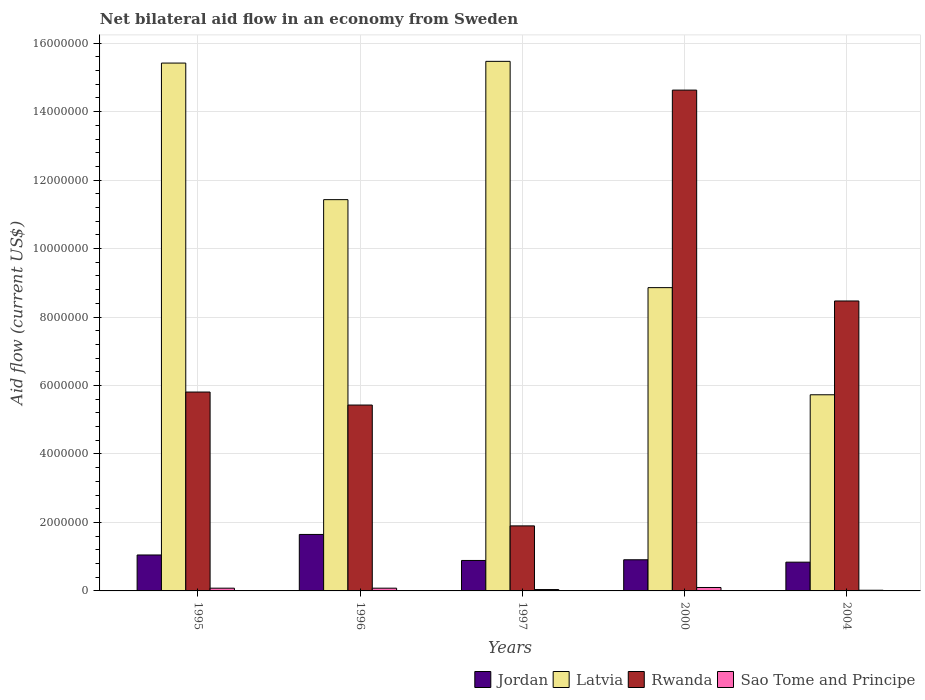How many groups of bars are there?
Ensure brevity in your answer.  5. How many bars are there on the 2nd tick from the left?
Your answer should be very brief. 4. What is the label of the 1st group of bars from the left?
Ensure brevity in your answer.  1995. In how many cases, is the number of bars for a given year not equal to the number of legend labels?
Provide a succinct answer. 0. Across all years, what is the maximum net bilateral aid flow in Latvia?
Your response must be concise. 1.55e+07. Across all years, what is the minimum net bilateral aid flow in Latvia?
Give a very brief answer. 5.73e+06. In which year was the net bilateral aid flow in Sao Tome and Principe maximum?
Keep it short and to the point. 2000. In which year was the net bilateral aid flow in Jordan minimum?
Offer a very short reply. 2004. What is the total net bilateral aid flow in Latvia in the graph?
Ensure brevity in your answer.  5.69e+07. What is the difference between the net bilateral aid flow in Jordan in 1996 and that in 2004?
Provide a succinct answer. 8.10e+05. What is the difference between the net bilateral aid flow in Latvia in 1997 and the net bilateral aid flow in Sao Tome and Principe in 1996?
Offer a terse response. 1.54e+07. What is the average net bilateral aid flow in Sao Tome and Principe per year?
Give a very brief answer. 6.40e+04. In the year 2000, what is the difference between the net bilateral aid flow in Sao Tome and Principe and net bilateral aid flow in Jordan?
Provide a short and direct response. -8.10e+05. In how many years, is the net bilateral aid flow in Jordan greater than 10000000 US$?
Your answer should be compact. 0. What is the difference between the highest and the second highest net bilateral aid flow in Rwanda?
Your answer should be very brief. 6.16e+06. What is the difference between the highest and the lowest net bilateral aid flow in Latvia?
Ensure brevity in your answer.  9.74e+06. Is the sum of the net bilateral aid flow in Rwanda in 1997 and 2000 greater than the maximum net bilateral aid flow in Sao Tome and Principe across all years?
Offer a very short reply. Yes. Is it the case that in every year, the sum of the net bilateral aid flow in Rwanda and net bilateral aid flow in Jordan is greater than the sum of net bilateral aid flow in Sao Tome and Principe and net bilateral aid flow in Latvia?
Give a very brief answer. Yes. What does the 1st bar from the left in 1996 represents?
Keep it short and to the point. Jordan. What does the 1st bar from the right in 2004 represents?
Ensure brevity in your answer.  Sao Tome and Principe. What is the difference between two consecutive major ticks on the Y-axis?
Provide a succinct answer. 2.00e+06. Are the values on the major ticks of Y-axis written in scientific E-notation?
Your response must be concise. No. Does the graph contain grids?
Ensure brevity in your answer.  Yes. Where does the legend appear in the graph?
Ensure brevity in your answer.  Bottom right. What is the title of the graph?
Offer a terse response. Net bilateral aid flow in an economy from Sweden. What is the label or title of the X-axis?
Offer a very short reply. Years. What is the Aid flow (current US$) in Jordan in 1995?
Give a very brief answer. 1.05e+06. What is the Aid flow (current US$) of Latvia in 1995?
Your answer should be compact. 1.54e+07. What is the Aid flow (current US$) of Rwanda in 1995?
Keep it short and to the point. 5.81e+06. What is the Aid flow (current US$) in Sao Tome and Principe in 1995?
Provide a short and direct response. 8.00e+04. What is the Aid flow (current US$) in Jordan in 1996?
Your response must be concise. 1.65e+06. What is the Aid flow (current US$) of Latvia in 1996?
Offer a very short reply. 1.14e+07. What is the Aid flow (current US$) in Rwanda in 1996?
Provide a succinct answer. 5.43e+06. What is the Aid flow (current US$) in Sao Tome and Principe in 1996?
Provide a short and direct response. 8.00e+04. What is the Aid flow (current US$) of Jordan in 1997?
Ensure brevity in your answer.  8.90e+05. What is the Aid flow (current US$) in Latvia in 1997?
Your answer should be very brief. 1.55e+07. What is the Aid flow (current US$) of Rwanda in 1997?
Your answer should be compact. 1.90e+06. What is the Aid flow (current US$) in Jordan in 2000?
Offer a terse response. 9.10e+05. What is the Aid flow (current US$) of Latvia in 2000?
Offer a very short reply. 8.86e+06. What is the Aid flow (current US$) of Rwanda in 2000?
Give a very brief answer. 1.46e+07. What is the Aid flow (current US$) of Sao Tome and Principe in 2000?
Your answer should be compact. 1.00e+05. What is the Aid flow (current US$) of Jordan in 2004?
Your answer should be compact. 8.40e+05. What is the Aid flow (current US$) of Latvia in 2004?
Ensure brevity in your answer.  5.73e+06. What is the Aid flow (current US$) in Rwanda in 2004?
Your answer should be compact. 8.47e+06. What is the Aid flow (current US$) in Sao Tome and Principe in 2004?
Offer a terse response. 2.00e+04. Across all years, what is the maximum Aid flow (current US$) of Jordan?
Keep it short and to the point. 1.65e+06. Across all years, what is the maximum Aid flow (current US$) of Latvia?
Ensure brevity in your answer.  1.55e+07. Across all years, what is the maximum Aid flow (current US$) in Rwanda?
Keep it short and to the point. 1.46e+07. Across all years, what is the maximum Aid flow (current US$) in Sao Tome and Principe?
Your response must be concise. 1.00e+05. Across all years, what is the minimum Aid flow (current US$) of Jordan?
Provide a short and direct response. 8.40e+05. Across all years, what is the minimum Aid flow (current US$) of Latvia?
Provide a short and direct response. 5.73e+06. Across all years, what is the minimum Aid flow (current US$) of Rwanda?
Provide a short and direct response. 1.90e+06. Across all years, what is the minimum Aid flow (current US$) of Sao Tome and Principe?
Provide a succinct answer. 2.00e+04. What is the total Aid flow (current US$) in Jordan in the graph?
Provide a short and direct response. 5.34e+06. What is the total Aid flow (current US$) in Latvia in the graph?
Offer a terse response. 5.69e+07. What is the total Aid flow (current US$) of Rwanda in the graph?
Make the answer very short. 3.62e+07. What is the difference between the Aid flow (current US$) of Jordan in 1995 and that in 1996?
Provide a short and direct response. -6.00e+05. What is the difference between the Aid flow (current US$) in Latvia in 1995 and that in 1996?
Keep it short and to the point. 3.99e+06. What is the difference between the Aid flow (current US$) in Rwanda in 1995 and that in 1996?
Your answer should be very brief. 3.80e+05. What is the difference between the Aid flow (current US$) of Sao Tome and Principe in 1995 and that in 1996?
Keep it short and to the point. 0. What is the difference between the Aid flow (current US$) in Jordan in 1995 and that in 1997?
Keep it short and to the point. 1.60e+05. What is the difference between the Aid flow (current US$) of Rwanda in 1995 and that in 1997?
Provide a short and direct response. 3.91e+06. What is the difference between the Aid flow (current US$) of Latvia in 1995 and that in 2000?
Make the answer very short. 6.56e+06. What is the difference between the Aid flow (current US$) of Rwanda in 1995 and that in 2000?
Provide a short and direct response. -8.82e+06. What is the difference between the Aid flow (current US$) in Sao Tome and Principe in 1995 and that in 2000?
Your answer should be compact. -2.00e+04. What is the difference between the Aid flow (current US$) of Latvia in 1995 and that in 2004?
Provide a short and direct response. 9.69e+06. What is the difference between the Aid flow (current US$) of Rwanda in 1995 and that in 2004?
Your answer should be very brief. -2.66e+06. What is the difference between the Aid flow (current US$) in Sao Tome and Principe in 1995 and that in 2004?
Your response must be concise. 6.00e+04. What is the difference between the Aid flow (current US$) of Jordan in 1996 and that in 1997?
Make the answer very short. 7.60e+05. What is the difference between the Aid flow (current US$) in Latvia in 1996 and that in 1997?
Offer a very short reply. -4.04e+06. What is the difference between the Aid flow (current US$) of Rwanda in 1996 and that in 1997?
Your answer should be compact. 3.53e+06. What is the difference between the Aid flow (current US$) of Jordan in 1996 and that in 2000?
Offer a very short reply. 7.40e+05. What is the difference between the Aid flow (current US$) of Latvia in 1996 and that in 2000?
Your answer should be very brief. 2.57e+06. What is the difference between the Aid flow (current US$) in Rwanda in 1996 and that in 2000?
Your answer should be very brief. -9.20e+06. What is the difference between the Aid flow (current US$) in Sao Tome and Principe in 1996 and that in 2000?
Your answer should be compact. -2.00e+04. What is the difference between the Aid flow (current US$) in Jordan in 1996 and that in 2004?
Your response must be concise. 8.10e+05. What is the difference between the Aid flow (current US$) of Latvia in 1996 and that in 2004?
Provide a short and direct response. 5.70e+06. What is the difference between the Aid flow (current US$) of Rwanda in 1996 and that in 2004?
Offer a very short reply. -3.04e+06. What is the difference between the Aid flow (current US$) in Sao Tome and Principe in 1996 and that in 2004?
Ensure brevity in your answer.  6.00e+04. What is the difference between the Aid flow (current US$) of Jordan in 1997 and that in 2000?
Your answer should be compact. -2.00e+04. What is the difference between the Aid flow (current US$) of Latvia in 1997 and that in 2000?
Give a very brief answer. 6.61e+06. What is the difference between the Aid flow (current US$) of Rwanda in 1997 and that in 2000?
Ensure brevity in your answer.  -1.27e+07. What is the difference between the Aid flow (current US$) of Sao Tome and Principe in 1997 and that in 2000?
Offer a very short reply. -6.00e+04. What is the difference between the Aid flow (current US$) in Jordan in 1997 and that in 2004?
Your answer should be compact. 5.00e+04. What is the difference between the Aid flow (current US$) in Latvia in 1997 and that in 2004?
Provide a succinct answer. 9.74e+06. What is the difference between the Aid flow (current US$) in Rwanda in 1997 and that in 2004?
Your response must be concise. -6.57e+06. What is the difference between the Aid flow (current US$) of Sao Tome and Principe in 1997 and that in 2004?
Offer a terse response. 2.00e+04. What is the difference between the Aid flow (current US$) of Jordan in 2000 and that in 2004?
Your response must be concise. 7.00e+04. What is the difference between the Aid flow (current US$) of Latvia in 2000 and that in 2004?
Your answer should be very brief. 3.13e+06. What is the difference between the Aid flow (current US$) of Rwanda in 2000 and that in 2004?
Your answer should be compact. 6.16e+06. What is the difference between the Aid flow (current US$) in Sao Tome and Principe in 2000 and that in 2004?
Keep it short and to the point. 8.00e+04. What is the difference between the Aid flow (current US$) in Jordan in 1995 and the Aid flow (current US$) in Latvia in 1996?
Your answer should be compact. -1.04e+07. What is the difference between the Aid flow (current US$) in Jordan in 1995 and the Aid flow (current US$) in Rwanda in 1996?
Offer a terse response. -4.38e+06. What is the difference between the Aid flow (current US$) of Jordan in 1995 and the Aid flow (current US$) of Sao Tome and Principe in 1996?
Offer a terse response. 9.70e+05. What is the difference between the Aid flow (current US$) of Latvia in 1995 and the Aid flow (current US$) of Rwanda in 1996?
Your response must be concise. 9.99e+06. What is the difference between the Aid flow (current US$) of Latvia in 1995 and the Aid flow (current US$) of Sao Tome and Principe in 1996?
Give a very brief answer. 1.53e+07. What is the difference between the Aid flow (current US$) in Rwanda in 1995 and the Aid flow (current US$) in Sao Tome and Principe in 1996?
Your response must be concise. 5.73e+06. What is the difference between the Aid flow (current US$) of Jordan in 1995 and the Aid flow (current US$) of Latvia in 1997?
Your answer should be very brief. -1.44e+07. What is the difference between the Aid flow (current US$) of Jordan in 1995 and the Aid flow (current US$) of Rwanda in 1997?
Offer a very short reply. -8.50e+05. What is the difference between the Aid flow (current US$) in Jordan in 1995 and the Aid flow (current US$) in Sao Tome and Principe in 1997?
Keep it short and to the point. 1.01e+06. What is the difference between the Aid flow (current US$) of Latvia in 1995 and the Aid flow (current US$) of Rwanda in 1997?
Your answer should be compact. 1.35e+07. What is the difference between the Aid flow (current US$) in Latvia in 1995 and the Aid flow (current US$) in Sao Tome and Principe in 1997?
Make the answer very short. 1.54e+07. What is the difference between the Aid flow (current US$) of Rwanda in 1995 and the Aid flow (current US$) of Sao Tome and Principe in 1997?
Your response must be concise. 5.77e+06. What is the difference between the Aid flow (current US$) of Jordan in 1995 and the Aid flow (current US$) of Latvia in 2000?
Your answer should be very brief. -7.81e+06. What is the difference between the Aid flow (current US$) of Jordan in 1995 and the Aid flow (current US$) of Rwanda in 2000?
Ensure brevity in your answer.  -1.36e+07. What is the difference between the Aid flow (current US$) in Jordan in 1995 and the Aid flow (current US$) in Sao Tome and Principe in 2000?
Provide a succinct answer. 9.50e+05. What is the difference between the Aid flow (current US$) in Latvia in 1995 and the Aid flow (current US$) in Rwanda in 2000?
Give a very brief answer. 7.90e+05. What is the difference between the Aid flow (current US$) in Latvia in 1995 and the Aid flow (current US$) in Sao Tome and Principe in 2000?
Offer a very short reply. 1.53e+07. What is the difference between the Aid flow (current US$) of Rwanda in 1995 and the Aid flow (current US$) of Sao Tome and Principe in 2000?
Give a very brief answer. 5.71e+06. What is the difference between the Aid flow (current US$) of Jordan in 1995 and the Aid flow (current US$) of Latvia in 2004?
Offer a terse response. -4.68e+06. What is the difference between the Aid flow (current US$) in Jordan in 1995 and the Aid flow (current US$) in Rwanda in 2004?
Provide a succinct answer. -7.42e+06. What is the difference between the Aid flow (current US$) in Jordan in 1995 and the Aid flow (current US$) in Sao Tome and Principe in 2004?
Your response must be concise. 1.03e+06. What is the difference between the Aid flow (current US$) of Latvia in 1995 and the Aid flow (current US$) of Rwanda in 2004?
Offer a very short reply. 6.95e+06. What is the difference between the Aid flow (current US$) of Latvia in 1995 and the Aid flow (current US$) of Sao Tome and Principe in 2004?
Give a very brief answer. 1.54e+07. What is the difference between the Aid flow (current US$) in Rwanda in 1995 and the Aid flow (current US$) in Sao Tome and Principe in 2004?
Provide a succinct answer. 5.79e+06. What is the difference between the Aid flow (current US$) of Jordan in 1996 and the Aid flow (current US$) of Latvia in 1997?
Offer a very short reply. -1.38e+07. What is the difference between the Aid flow (current US$) of Jordan in 1996 and the Aid flow (current US$) of Sao Tome and Principe in 1997?
Ensure brevity in your answer.  1.61e+06. What is the difference between the Aid flow (current US$) of Latvia in 1996 and the Aid flow (current US$) of Rwanda in 1997?
Provide a short and direct response. 9.53e+06. What is the difference between the Aid flow (current US$) in Latvia in 1996 and the Aid flow (current US$) in Sao Tome and Principe in 1997?
Your answer should be compact. 1.14e+07. What is the difference between the Aid flow (current US$) in Rwanda in 1996 and the Aid flow (current US$) in Sao Tome and Principe in 1997?
Provide a short and direct response. 5.39e+06. What is the difference between the Aid flow (current US$) of Jordan in 1996 and the Aid flow (current US$) of Latvia in 2000?
Give a very brief answer. -7.21e+06. What is the difference between the Aid flow (current US$) in Jordan in 1996 and the Aid flow (current US$) in Rwanda in 2000?
Offer a very short reply. -1.30e+07. What is the difference between the Aid flow (current US$) of Jordan in 1996 and the Aid flow (current US$) of Sao Tome and Principe in 2000?
Provide a short and direct response. 1.55e+06. What is the difference between the Aid flow (current US$) in Latvia in 1996 and the Aid flow (current US$) in Rwanda in 2000?
Provide a succinct answer. -3.20e+06. What is the difference between the Aid flow (current US$) in Latvia in 1996 and the Aid flow (current US$) in Sao Tome and Principe in 2000?
Your answer should be very brief. 1.13e+07. What is the difference between the Aid flow (current US$) in Rwanda in 1996 and the Aid flow (current US$) in Sao Tome and Principe in 2000?
Make the answer very short. 5.33e+06. What is the difference between the Aid flow (current US$) of Jordan in 1996 and the Aid flow (current US$) of Latvia in 2004?
Ensure brevity in your answer.  -4.08e+06. What is the difference between the Aid flow (current US$) of Jordan in 1996 and the Aid flow (current US$) of Rwanda in 2004?
Your response must be concise. -6.82e+06. What is the difference between the Aid flow (current US$) of Jordan in 1996 and the Aid flow (current US$) of Sao Tome and Principe in 2004?
Your answer should be very brief. 1.63e+06. What is the difference between the Aid flow (current US$) in Latvia in 1996 and the Aid flow (current US$) in Rwanda in 2004?
Make the answer very short. 2.96e+06. What is the difference between the Aid flow (current US$) of Latvia in 1996 and the Aid flow (current US$) of Sao Tome and Principe in 2004?
Your response must be concise. 1.14e+07. What is the difference between the Aid flow (current US$) of Rwanda in 1996 and the Aid flow (current US$) of Sao Tome and Principe in 2004?
Your answer should be compact. 5.41e+06. What is the difference between the Aid flow (current US$) of Jordan in 1997 and the Aid flow (current US$) of Latvia in 2000?
Your answer should be compact. -7.97e+06. What is the difference between the Aid flow (current US$) of Jordan in 1997 and the Aid flow (current US$) of Rwanda in 2000?
Offer a terse response. -1.37e+07. What is the difference between the Aid flow (current US$) of Jordan in 1997 and the Aid flow (current US$) of Sao Tome and Principe in 2000?
Provide a succinct answer. 7.90e+05. What is the difference between the Aid flow (current US$) in Latvia in 1997 and the Aid flow (current US$) in Rwanda in 2000?
Offer a terse response. 8.40e+05. What is the difference between the Aid flow (current US$) in Latvia in 1997 and the Aid flow (current US$) in Sao Tome and Principe in 2000?
Provide a short and direct response. 1.54e+07. What is the difference between the Aid flow (current US$) in Rwanda in 1997 and the Aid flow (current US$) in Sao Tome and Principe in 2000?
Give a very brief answer. 1.80e+06. What is the difference between the Aid flow (current US$) in Jordan in 1997 and the Aid flow (current US$) in Latvia in 2004?
Make the answer very short. -4.84e+06. What is the difference between the Aid flow (current US$) of Jordan in 1997 and the Aid flow (current US$) of Rwanda in 2004?
Offer a terse response. -7.58e+06. What is the difference between the Aid flow (current US$) of Jordan in 1997 and the Aid flow (current US$) of Sao Tome and Principe in 2004?
Your answer should be compact. 8.70e+05. What is the difference between the Aid flow (current US$) in Latvia in 1997 and the Aid flow (current US$) in Sao Tome and Principe in 2004?
Offer a very short reply. 1.54e+07. What is the difference between the Aid flow (current US$) of Rwanda in 1997 and the Aid flow (current US$) of Sao Tome and Principe in 2004?
Provide a succinct answer. 1.88e+06. What is the difference between the Aid flow (current US$) in Jordan in 2000 and the Aid flow (current US$) in Latvia in 2004?
Ensure brevity in your answer.  -4.82e+06. What is the difference between the Aid flow (current US$) in Jordan in 2000 and the Aid flow (current US$) in Rwanda in 2004?
Offer a very short reply. -7.56e+06. What is the difference between the Aid flow (current US$) in Jordan in 2000 and the Aid flow (current US$) in Sao Tome and Principe in 2004?
Offer a terse response. 8.90e+05. What is the difference between the Aid flow (current US$) of Latvia in 2000 and the Aid flow (current US$) of Sao Tome and Principe in 2004?
Make the answer very short. 8.84e+06. What is the difference between the Aid flow (current US$) of Rwanda in 2000 and the Aid flow (current US$) of Sao Tome and Principe in 2004?
Keep it short and to the point. 1.46e+07. What is the average Aid flow (current US$) in Jordan per year?
Give a very brief answer. 1.07e+06. What is the average Aid flow (current US$) of Latvia per year?
Offer a very short reply. 1.14e+07. What is the average Aid flow (current US$) of Rwanda per year?
Keep it short and to the point. 7.25e+06. What is the average Aid flow (current US$) of Sao Tome and Principe per year?
Offer a terse response. 6.40e+04. In the year 1995, what is the difference between the Aid flow (current US$) in Jordan and Aid flow (current US$) in Latvia?
Provide a short and direct response. -1.44e+07. In the year 1995, what is the difference between the Aid flow (current US$) in Jordan and Aid flow (current US$) in Rwanda?
Your answer should be very brief. -4.76e+06. In the year 1995, what is the difference between the Aid flow (current US$) of Jordan and Aid flow (current US$) of Sao Tome and Principe?
Give a very brief answer. 9.70e+05. In the year 1995, what is the difference between the Aid flow (current US$) of Latvia and Aid flow (current US$) of Rwanda?
Your response must be concise. 9.61e+06. In the year 1995, what is the difference between the Aid flow (current US$) of Latvia and Aid flow (current US$) of Sao Tome and Principe?
Keep it short and to the point. 1.53e+07. In the year 1995, what is the difference between the Aid flow (current US$) of Rwanda and Aid flow (current US$) of Sao Tome and Principe?
Keep it short and to the point. 5.73e+06. In the year 1996, what is the difference between the Aid flow (current US$) in Jordan and Aid flow (current US$) in Latvia?
Ensure brevity in your answer.  -9.78e+06. In the year 1996, what is the difference between the Aid flow (current US$) of Jordan and Aid flow (current US$) of Rwanda?
Keep it short and to the point. -3.78e+06. In the year 1996, what is the difference between the Aid flow (current US$) in Jordan and Aid flow (current US$) in Sao Tome and Principe?
Your answer should be very brief. 1.57e+06. In the year 1996, what is the difference between the Aid flow (current US$) of Latvia and Aid flow (current US$) of Sao Tome and Principe?
Your answer should be very brief. 1.14e+07. In the year 1996, what is the difference between the Aid flow (current US$) in Rwanda and Aid flow (current US$) in Sao Tome and Principe?
Keep it short and to the point. 5.35e+06. In the year 1997, what is the difference between the Aid flow (current US$) of Jordan and Aid flow (current US$) of Latvia?
Provide a succinct answer. -1.46e+07. In the year 1997, what is the difference between the Aid flow (current US$) of Jordan and Aid flow (current US$) of Rwanda?
Make the answer very short. -1.01e+06. In the year 1997, what is the difference between the Aid flow (current US$) in Jordan and Aid flow (current US$) in Sao Tome and Principe?
Your response must be concise. 8.50e+05. In the year 1997, what is the difference between the Aid flow (current US$) of Latvia and Aid flow (current US$) of Rwanda?
Offer a very short reply. 1.36e+07. In the year 1997, what is the difference between the Aid flow (current US$) in Latvia and Aid flow (current US$) in Sao Tome and Principe?
Give a very brief answer. 1.54e+07. In the year 1997, what is the difference between the Aid flow (current US$) of Rwanda and Aid flow (current US$) of Sao Tome and Principe?
Make the answer very short. 1.86e+06. In the year 2000, what is the difference between the Aid flow (current US$) of Jordan and Aid flow (current US$) of Latvia?
Provide a short and direct response. -7.95e+06. In the year 2000, what is the difference between the Aid flow (current US$) of Jordan and Aid flow (current US$) of Rwanda?
Provide a short and direct response. -1.37e+07. In the year 2000, what is the difference between the Aid flow (current US$) of Jordan and Aid flow (current US$) of Sao Tome and Principe?
Give a very brief answer. 8.10e+05. In the year 2000, what is the difference between the Aid flow (current US$) of Latvia and Aid flow (current US$) of Rwanda?
Provide a short and direct response. -5.77e+06. In the year 2000, what is the difference between the Aid flow (current US$) of Latvia and Aid flow (current US$) of Sao Tome and Principe?
Keep it short and to the point. 8.76e+06. In the year 2000, what is the difference between the Aid flow (current US$) of Rwanda and Aid flow (current US$) of Sao Tome and Principe?
Your answer should be very brief. 1.45e+07. In the year 2004, what is the difference between the Aid flow (current US$) in Jordan and Aid flow (current US$) in Latvia?
Offer a terse response. -4.89e+06. In the year 2004, what is the difference between the Aid flow (current US$) of Jordan and Aid flow (current US$) of Rwanda?
Give a very brief answer. -7.63e+06. In the year 2004, what is the difference between the Aid flow (current US$) in Jordan and Aid flow (current US$) in Sao Tome and Principe?
Give a very brief answer. 8.20e+05. In the year 2004, what is the difference between the Aid flow (current US$) in Latvia and Aid flow (current US$) in Rwanda?
Your answer should be very brief. -2.74e+06. In the year 2004, what is the difference between the Aid flow (current US$) in Latvia and Aid flow (current US$) in Sao Tome and Principe?
Offer a very short reply. 5.71e+06. In the year 2004, what is the difference between the Aid flow (current US$) in Rwanda and Aid flow (current US$) in Sao Tome and Principe?
Offer a terse response. 8.45e+06. What is the ratio of the Aid flow (current US$) of Jordan in 1995 to that in 1996?
Offer a very short reply. 0.64. What is the ratio of the Aid flow (current US$) in Latvia in 1995 to that in 1996?
Provide a short and direct response. 1.35. What is the ratio of the Aid flow (current US$) of Rwanda in 1995 to that in 1996?
Your answer should be very brief. 1.07. What is the ratio of the Aid flow (current US$) of Jordan in 1995 to that in 1997?
Make the answer very short. 1.18. What is the ratio of the Aid flow (current US$) in Rwanda in 1995 to that in 1997?
Provide a short and direct response. 3.06. What is the ratio of the Aid flow (current US$) in Jordan in 1995 to that in 2000?
Keep it short and to the point. 1.15. What is the ratio of the Aid flow (current US$) of Latvia in 1995 to that in 2000?
Make the answer very short. 1.74. What is the ratio of the Aid flow (current US$) of Rwanda in 1995 to that in 2000?
Offer a very short reply. 0.4. What is the ratio of the Aid flow (current US$) in Sao Tome and Principe in 1995 to that in 2000?
Your answer should be compact. 0.8. What is the ratio of the Aid flow (current US$) in Latvia in 1995 to that in 2004?
Offer a very short reply. 2.69. What is the ratio of the Aid flow (current US$) in Rwanda in 1995 to that in 2004?
Provide a short and direct response. 0.69. What is the ratio of the Aid flow (current US$) in Sao Tome and Principe in 1995 to that in 2004?
Your response must be concise. 4. What is the ratio of the Aid flow (current US$) of Jordan in 1996 to that in 1997?
Offer a terse response. 1.85. What is the ratio of the Aid flow (current US$) of Latvia in 1996 to that in 1997?
Provide a succinct answer. 0.74. What is the ratio of the Aid flow (current US$) of Rwanda in 1996 to that in 1997?
Keep it short and to the point. 2.86. What is the ratio of the Aid flow (current US$) of Sao Tome and Principe in 1996 to that in 1997?
Give a very brief answer. 2. What is the ratio of the Aid flow (current US$) of Jordan in 1996 to that in 2000?
Offer a terse response. 1.81. What is the ratio of the Aid flow (current US$) in Latvia in 1996 to that in 2000?
Offer a terse response. 1.29. What is the ratio of the Aid flow (current US$) of Rwanda in 1996 to that in 2000?
Provide a succinct answer. 0.37. What is the ratio of the Aid flow (current US$) in Sao Tome and Principe in 1996 to that in 2000?
Your response must be concise. 0.8. What is the ratio of the Aid flow (current US$) of Jordan in 1996 to that in 2004?
Provide a short and direct response. 1.96. What is the ratio of the Aid flow (current US$) of Latvia in 1996 to that in 2004?
Your answer should be compact. 1.99. What is the ratio of the Aid flow (current US$) in Rwanda in 1996 to that in 2004?
Give a very brief answer. 0.64. What is the ratio of the Aid flow (current US$) in Sao Tome and Principe in 1996 to that in 2004?
Provide a short and direct response. 4. What is the ratio of the Aid flow (current US$) of Jordan in 1997 to that in 2000?
Keep it short and to the point. 0.98. What is the ratio of the Aid flow (current US$) of Latvia in 1997 to that in 2000?
Offer a terse response. 1.75. What is the ratio of the Aid flow (current US$) in Rwanda in 1997 to that in 2000?
Your answer should be very brief. 0.13. What is the ratio of the Aid flow (current US$) of Sao Tome and Principe in 1997 to that in 2000?
Offer a very short reply. 0.4. What is the ratio of the Aid flow (current US$) of Jordan in 1997 to that in 2004?
Your answer should be compact. 1.06. What is the ratio of the Aid flow (current US$) in Latvia in 1997 to that in 2004?
Your answer should be very brief. 2.7. What is the ratio of the Aid flow (current US$) of Rwanda in 1997 to that in 2004?
Provide a short and direct response. 0.22. What is the ratio of the Aid flow (current US$) of Latvia in 2000 to that in 2004?
Make the answer very short. 1.55. What is the ratio of the Aid flow (current US$) of Rwanda in 2000 to that in 2004?
Your response must be concise. 1.73. What is the ratio of the Aid flow (current US$) in Sao Tome and Principe in 2000 to that in 2004?
Provide a succinct answer. 5. What is the difference between the highest and the second highest Aid flow (current US$) in Latvia?
Offer a very short reply. 5.00e+04. What is the difference between the highest and the second highest Aid flow (current US$) of Rwanda?
Make the answer very short. 6.16e+06. What is the difference between the highest and the second highest Aid flow (current US$) in Sao Tome and Principe?
Ensure brevity in your answer.  2.00e+04. What is the difference between the highest and the lowest Aid flow (current US$) in Jordan?
Provide a succinct answer. 8.10e+05. What is the difference between the highest and the lowest Aid flow (current US$) in Latvia?
Provide a short and direct response. 9.74e+06. What is the difference between the highest and the lowest Aid flow (current US$) of Rwanda?
Provide a succinct answer. 1.27e+07. 